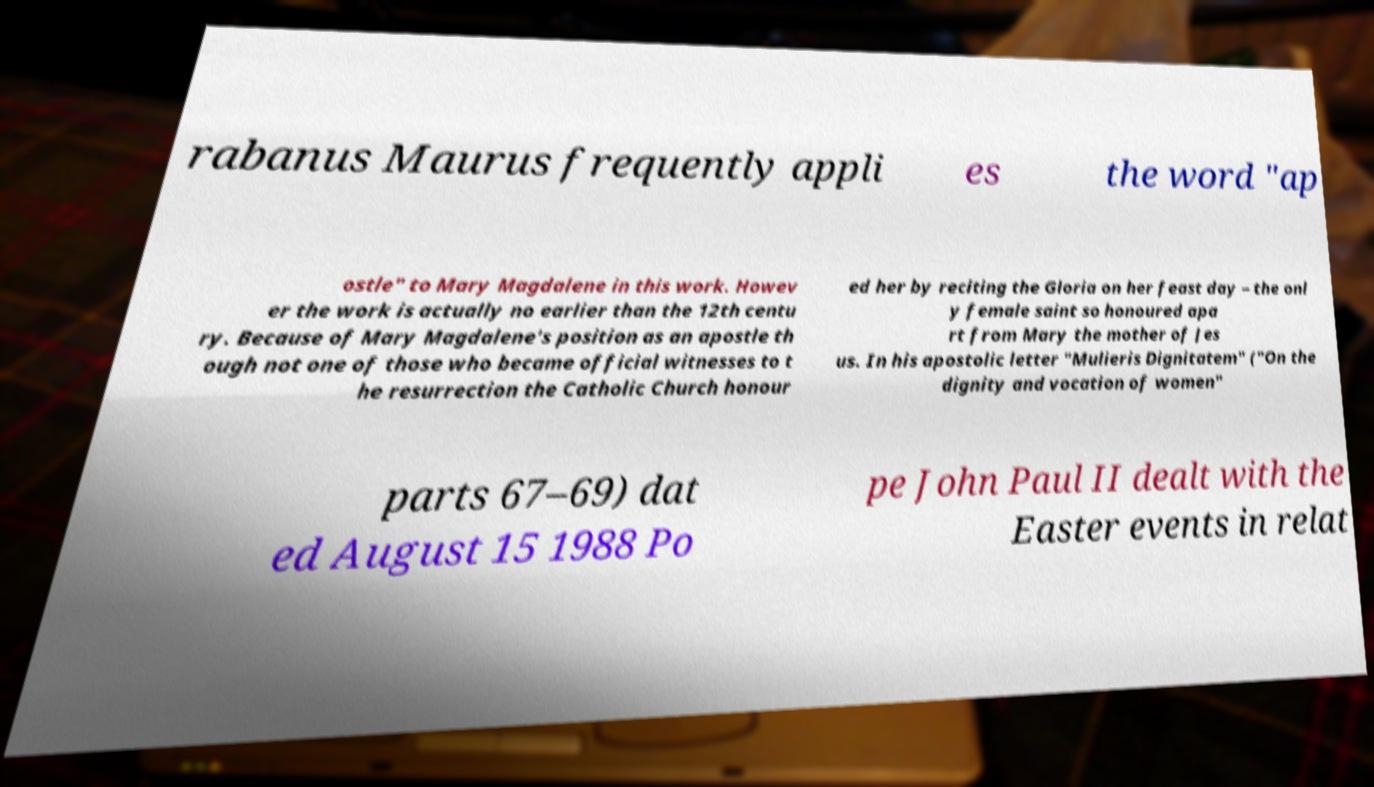Please identify and transcribe the text found in this image. rabanus Maurus frequently appli es the word "ap ostle" to Mary Magdalene in this work. Howev er the work is actually no earlier than the 12th centu ry. Because of Mary Magdalene's position as an apostle th ough not one of those who became official witnesses to t he resurrection the Catholic Church honour ed her by reciting the Gloria on her feast day – the onl y female saint so honoured apa rt from Mary the mother of Jes us. In his apostolic letter "Mulieris Dignitatem" ("On the dignity and vocation of women" parts 67–69) dat ed August 15 1988 Po pe John Paul II dealt with the Easter events in relat 